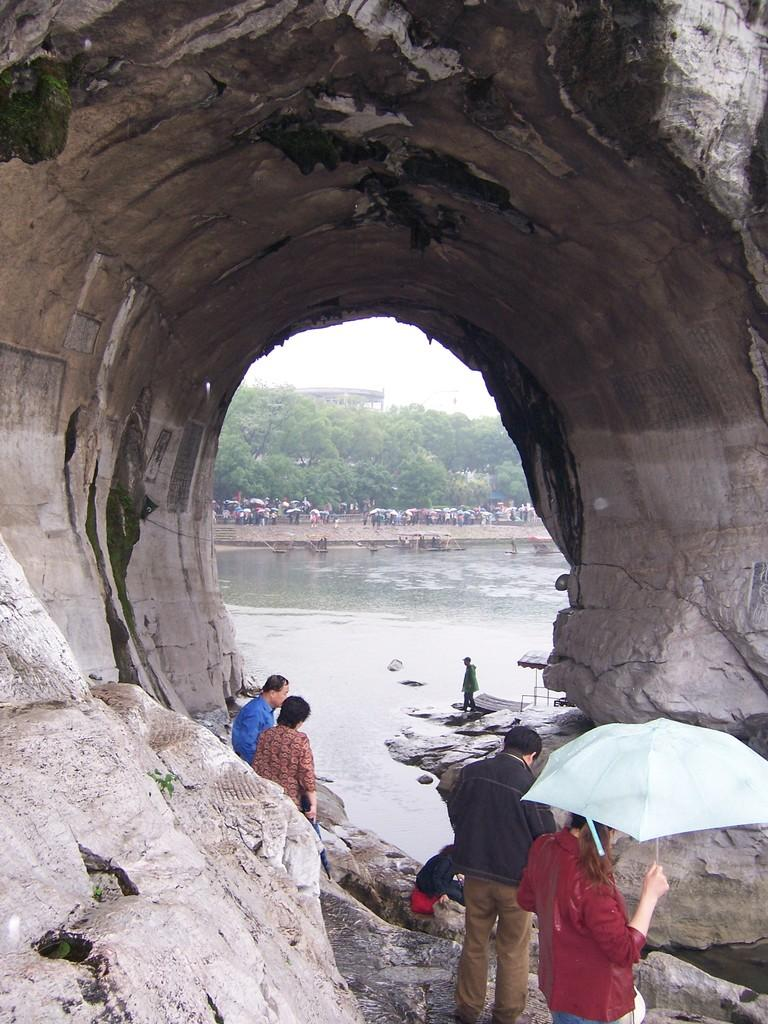Where are the persons located in the image? The persons are standing under a cave in the image. What can be seen in the background of the image? There are trees, people, and water visible in the background of the image. What type of truck can be seen driving through the cave in the image? There is no truck present in the image; it features persons standing under a cave with trees, people, and water visible in the background. 